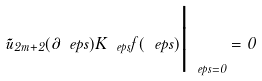<formula> <loc_0><loc_0><loc_500><loc_500>\tilde { u } _ { 2 m + 2 } ( \partial _ { \ } e p s ) K _ { \ e p s } f ( \ e p s ) \Big | _ { \ e p s = 0 } = 0</formula> 